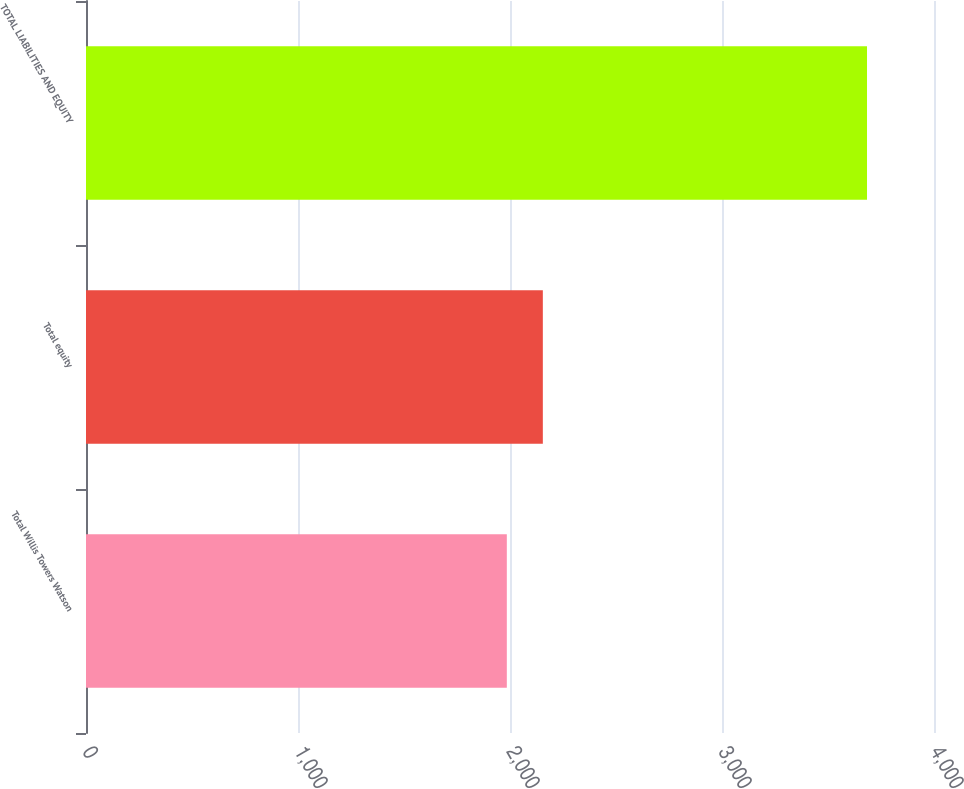<chart> <loc_0><loc_0><loc_500><loc_500><bar_chart><fcel>Total Willis Towers Watson<fcel>Total equity<fcel>TOTAL LIABILITIES AND EQUITY<nl><fcel>1985<fcel>2154.9<fcel>3684<nl></chart> 